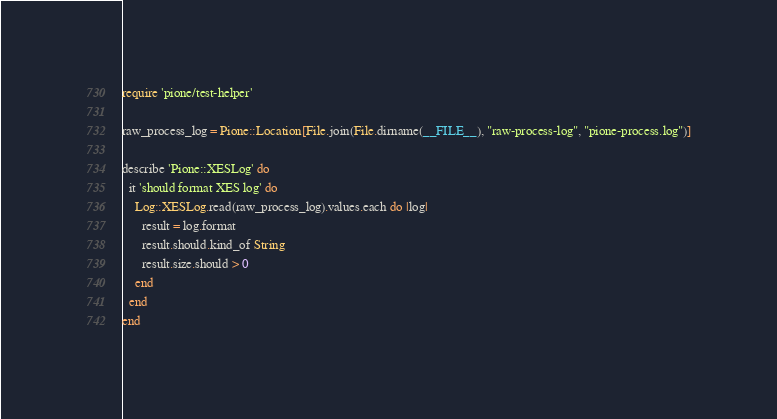Convert code to text. <code><loc_0><loc_0><loc_500><loc_500><_Ruby_>require 'pione/test-helper'

raw_process_log = Pione::Location[File.join(File.dirname(__FILE__), "raw-process-log", "pione-process.log")]

describe 'Pione::XESLog' do
  it 'should format XES log' do
    Log::XESLog.read(raw_process_log).values.each do |log|
      result = log.format
      result.should.kind_of String
      result.size.should > 0
    end
  end
end
</code> 